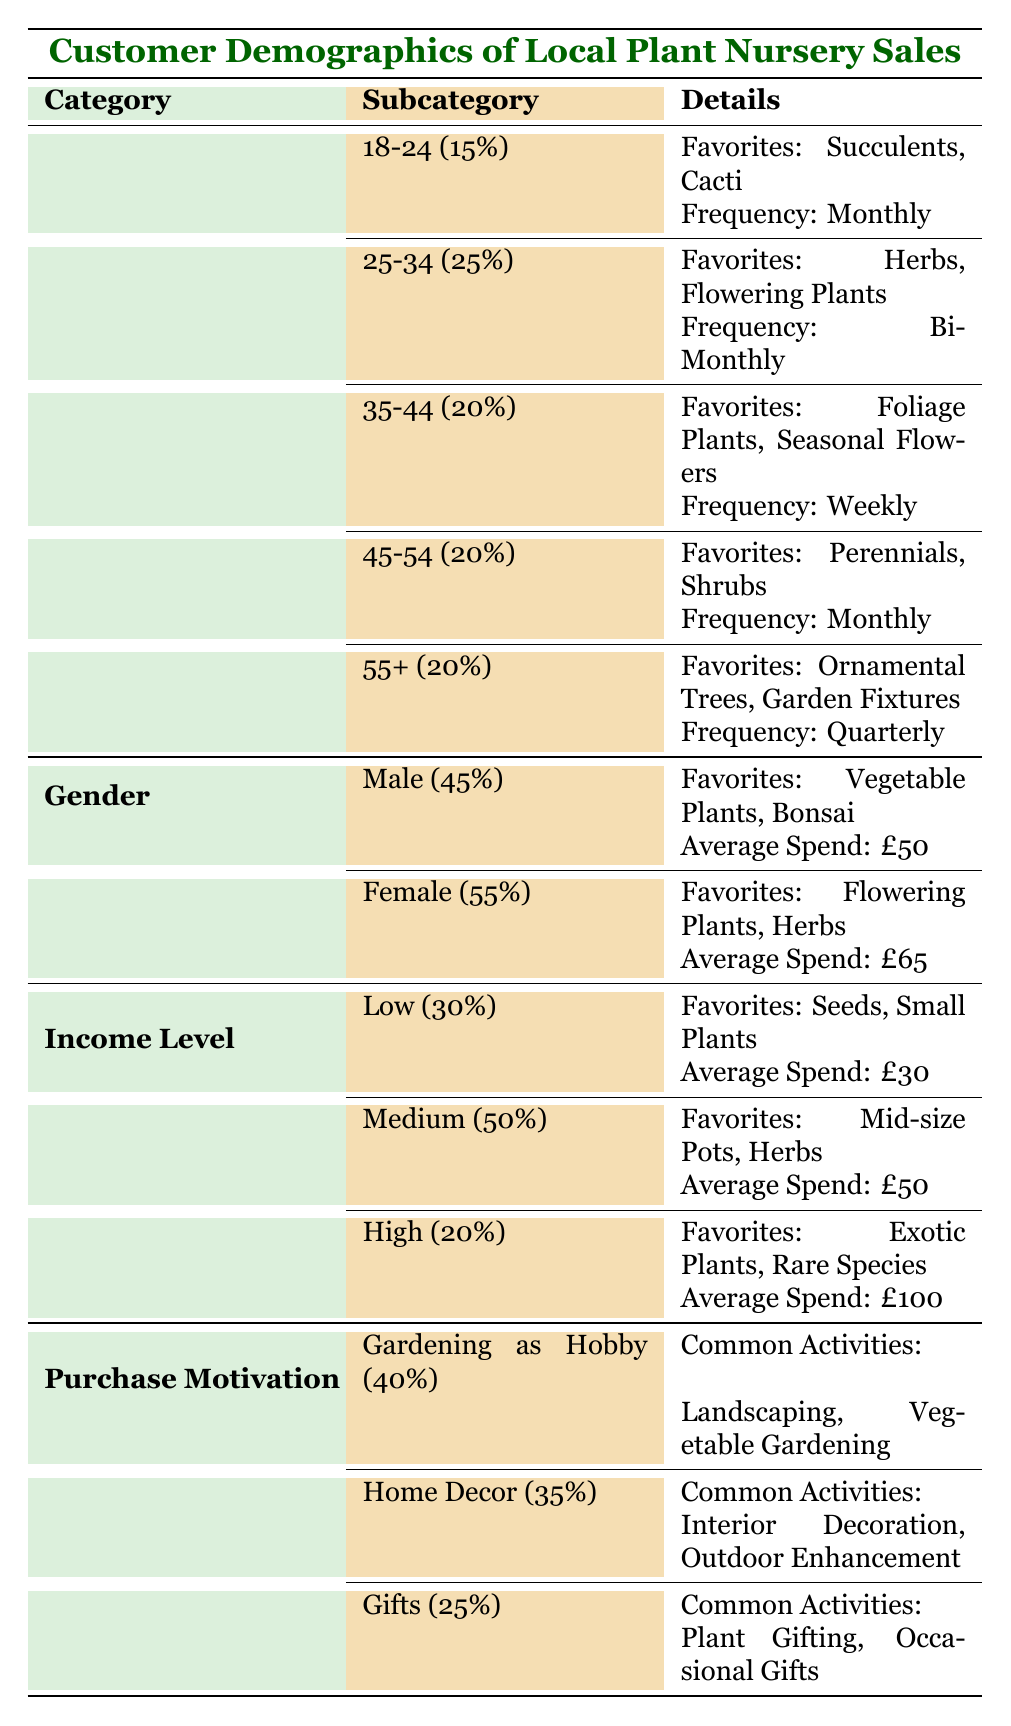What percentage of customers are aged 25-34? According to the table, the "25-34" age group comprises 25% of the customers.
Answer: 25% Which gender has the highest average spend? The table states that females have an average spend of £65, while males have £50. Therefore, females have the highest average spend.
Answer: Female How many customers are motivated by gardening as a hobby? The table indicates that 40% of customers are motivated by gardening as a hobby.
Answer: 40% Is it true that the majority of customers are male? The table shows that 45% of customers are male, while 55% are female. Therefore, it is false that the majority are male.
Answer: No What are the favorite plants for the age group 35-44? The table lists the favorite plants for the 35-44 age group as foliage plants and seasonal flowers.
Answer: Foliage plants, Seasonal flowers If we take the average spend of all income levels, what does it come to? The average spend for each income level is: Low (£30), Medium (£50), and High (£100). Therefore, (30 + 50 + 100) = 180. There are 3 levels, thus the average spend is 180/3 = £60.
Answer: £60 Which age group purchases plants most frequently? The table shows that the 35-44 age group purchases plants weekly, which is the most frequent among all groups.
Answer: 35-44 What percentage of customers purchase plants because of home decor? As per the table, 35% of customers are motivated by home decor.
Answer: 35% Do customers from high-income levels prefer vegetable plants? The table indicates that high-income customers favor exotic plants and rare species, not vegetable plants. Therefore, this statement is false.
Answer: No 